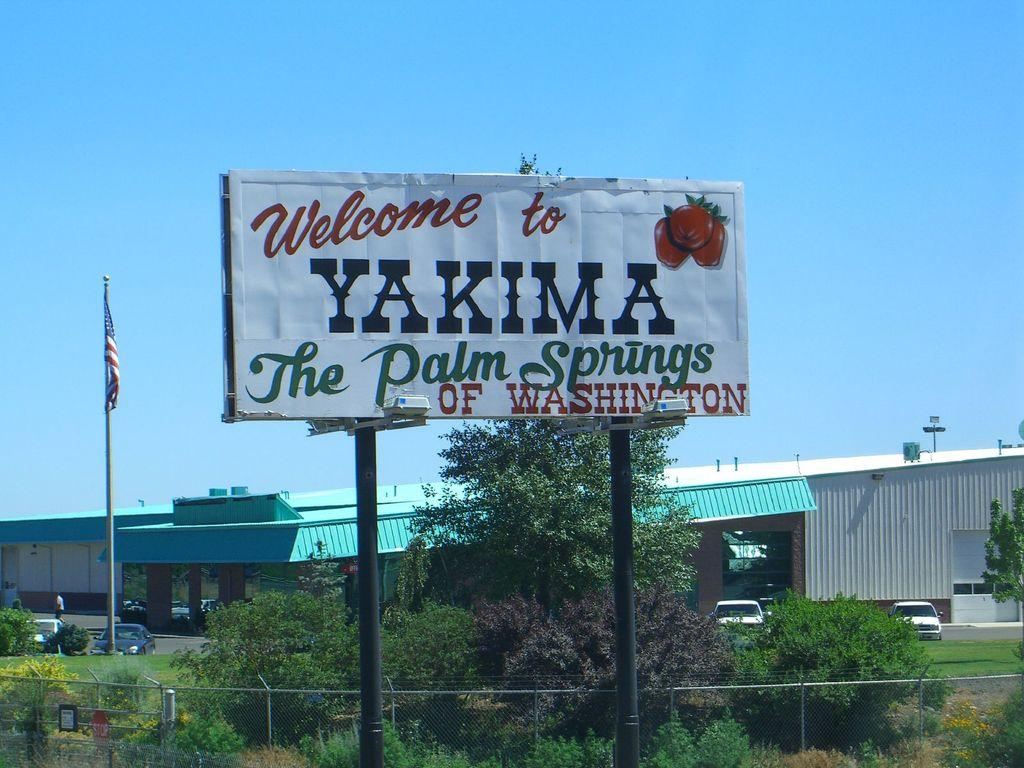<image>
Present a compact description of the photo's key features. An outdoor billboard with the words Welcome to Yakima on it. 